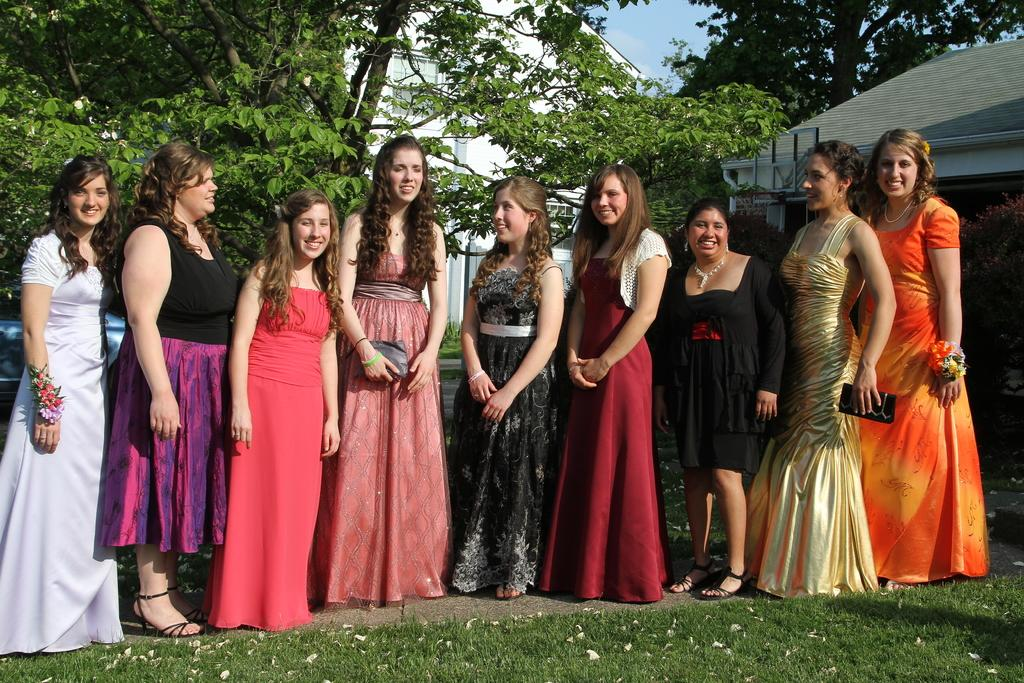What type of vegetation is present on the ground in the front of the image? There is grass on the ground in the front of the image. What is happening in the center of the image? There are women standing in the center of the image, and they are smiling. What can be seen in the background of the image? There are houses and trees in the background of the image. How would you describe the sky in the image? The sky is cloudy in the image. What type of wax is being used by the women in the image? There is no wax present in the image; the women are simply standing and smiling. What flavor of pie is being served in the image? There is no pie present in the image; it features women standing in a grassy area with houses and trees in the background. 